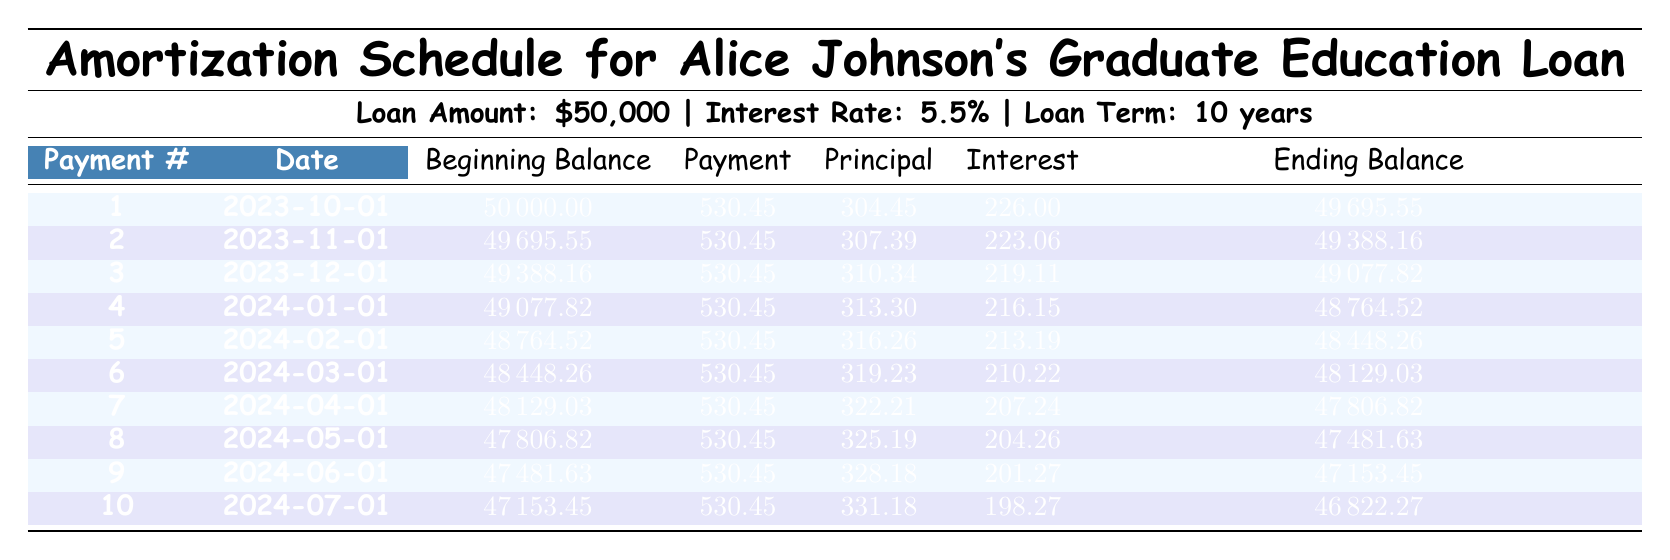What is the total amount of interest paid in the first payment? The interest payment for the first payment is explicitly listed in the table as 226.00.
Answer: 226.00 How much was the initial loan amount? The initial loan amount is clearly stated in the loan details as 50000.
Answer: 50000 What is the ending balance after the second payment? The ending balance is recorded for the second payment as 49388.16.
Answer: 49388.16 What is the difference in principal payment between the first and third payments? The principal payment for the first payment is 304.45, and for the third payment, it is 310.34. The difference is calculated as 310.34 - 304.45 = 5.89.
Answer: 5.89 Is the interest payment ever higher than the principal payment in any of the ten payments? By examining the table, the interest payment starts high but decreases gradually, while the principal payment increases. In every row, the principal payment is higher than the interest from payment 1 to payment 10. Thus, the answer is no.
Answer: No What is the sum of the principal payments for the first five payments? The principal payments for the first five payments are: 304.45 (1) + 307.39 (2) + 310.34 (3) + 313.30 (4) + 316.26 (5) = 1551.74.
Answer: 1551.74 What is the maximum ending balance after the first ten payments? To find the maximum ending balance, we compare the ending balances after each of the ten payments. The first ending balance is 49695.55, the second is 49388.16, and so on, with the maximum occurring at payment 1. The answer is 49695.55.
Answer: 49695.55 How much principal is paid in payment number 7? The table states that the principal payment for payment number 7 is 322.21.
Answer: 322.21 What is the average interest payment over the first ten payments? To find the average interest payment, sum each of the interest payments: 226.00 + 223.06 + 219.11 + 216.15 + 213.19 + 210.22 + 207.24 + 204.26 + 201.27 + 198.27 = 2118.82. Then divide that sum by 10 for the average: 2118.82 / 10 = 211.88.
Answer: 211.88 